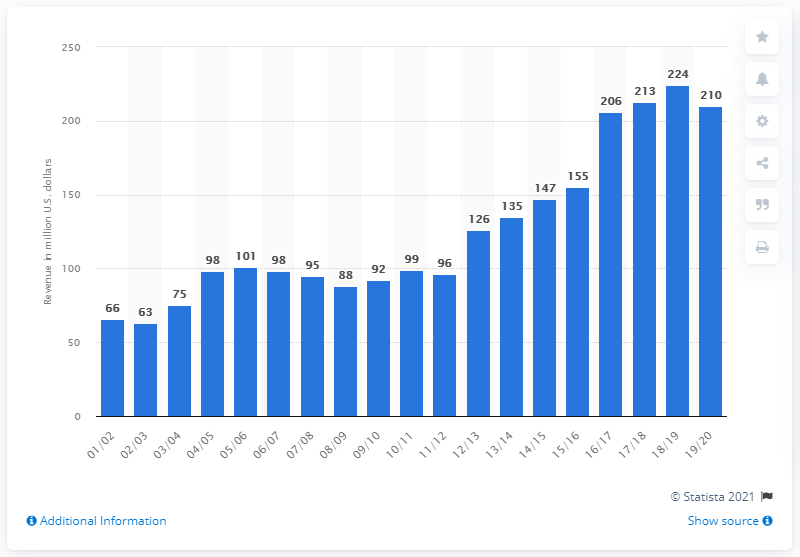Identify some key points in this picture. In the year 2019/20, the estimated revenue of the National Basketball Association was approximately 210 billion dollars. 